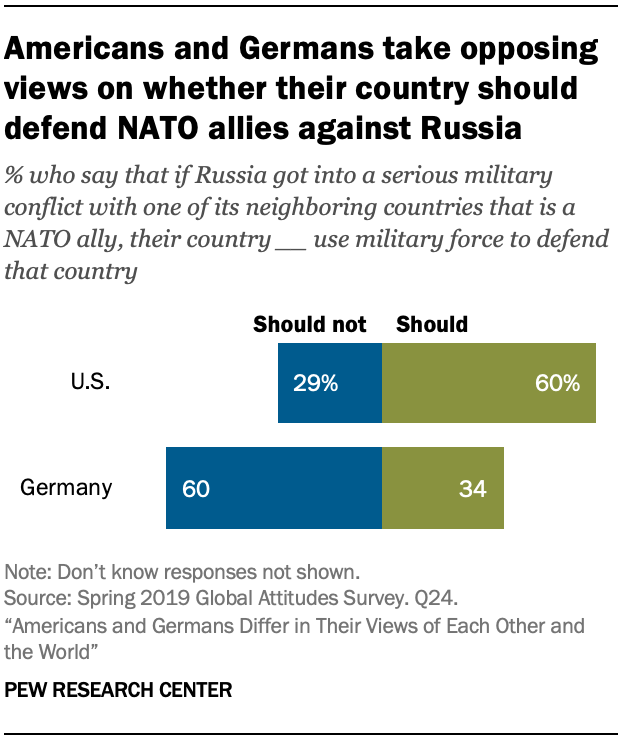Draw attention to some important aspects in this diagram. The ratio of the largest blue and green bars in the data provided is 0.042361111... In the United States, the percentage value of should bars is approximately 60%. 